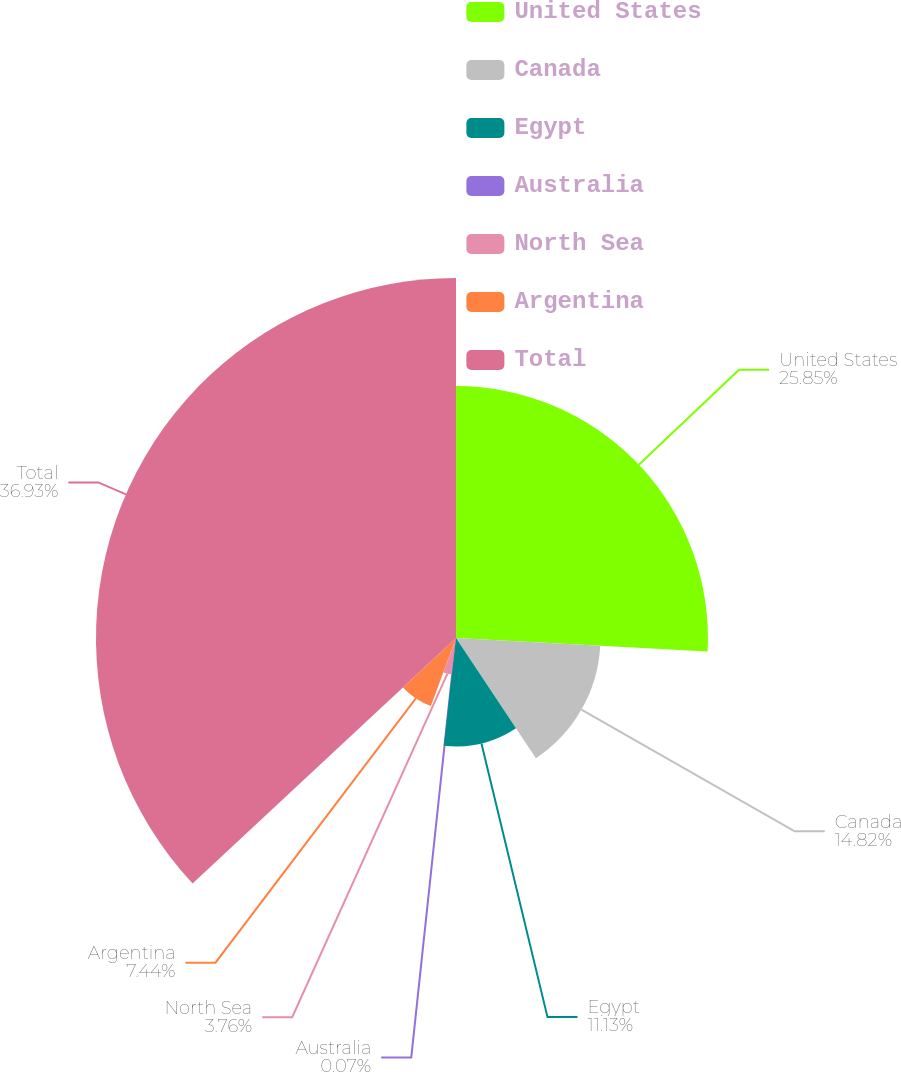<chart> <loc_0><loc_0><loc_500><loc_500><pie_chart><fcel>United States<fcel>Canada<fcel>Egypt<fcel>Australia<fcel>North Sea<fcel>Argentina<fcel>Total<nl><fcel>25.85%<fcel>14.82%<fcel>11.13%<fcel>0.07%<fcel>3.76%<fcel>7.44%<fcel>36.94%<nl></chart> 